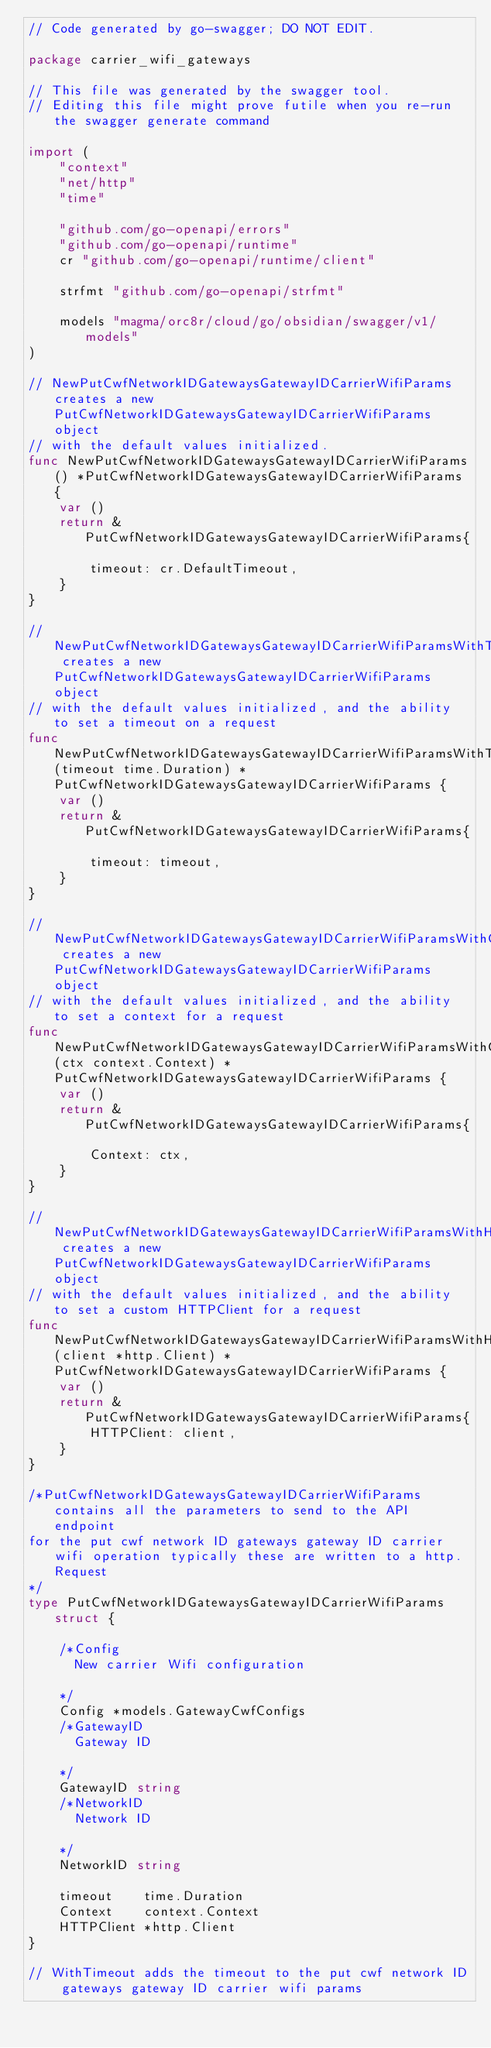<code> <loc_0><loc_0><loc_500><loc_500><_Go_>// Code generated by go-swagger; DO NOT EDIT.

package carrier_wifi_gateways

// This file was generated by the swagger tool.
// Editing this file might prove futile when you re-run the swagger generate command

import (
	"context"
	"net/http"
	"time"

	"github.com/go-openapi/errors"
	"github.com/go-openapi/runtime"
	cr "github.com/go-openapi/runtime/client"

	strfmt "github.com/go-openapi/strfmt"

	models "magma/orc8r/cloud/go/obsidian/swagger/v1/models"
)

// NewPutCwfNetworkIDGatewaysGatewayIDCarrierWifiParams creates a new PutCwfNetworkIDGatewaysGatewayIDCarrierWifiParams object
// with the default values initialized.
func NewPutCwfNetworkIDGatewaysGatewayIDCarrierWifiParams() *PutCwfNetworkIDGatewaysGatewayIDCarrierWifiParams {
	var ()
	return &PutCwfNetworkIDGatewaysGatewayIDCarrierWifiParams{

		timeout: cr.DefaultTimeout,
	}
}

// NewPutCwfNetworkIDGatewaysGatewayIDCarrierWifiParamsWithTimeout creates a new PutCwfNetworkIDGatewaysGatewayIDCarrierWifiParams object
// with the default values initialized, and the ability to set a timeout on a request
func NewPutCwfNetworkIDGatewaysGatewayIDCarrierWifiParamsWithTimeout(timeout time.Duration) *PutCwfNetworkIDGatewaysGatewayIDCarrierWifiParams {
	var ()
	return &PutCwfNetworkIDGatewaysGatewayIDCarrierWifiParams{

		timeout: timeout,
	}
}

// NewPutCwfNetworkIDGatewaysGatewayIDCarrierWifiParamsWithContext creates a new PutCwfNetworkIDGatewaysGatewayIDCarrierWifiParams object
// with the default values initialized, and the ability to set a context for a request
func NewPutCwfNetworkIDGatewaysGatewayIDCarrierWifiParamsWithContext(ctx context.Context) *PutCwfNetworkIDGatewaysGatewayIDCarrierWifiParams {
	var ()
	return &PutCwfNetworkIDGatewaysGatewayIDCarrierWifiParams{

		Context: ctx,
	}
}

// NewPutCwfNetworkIDGatewaysGatewayIDCarrierWifiParamsWithHTTPClient creates a new PutCwfNetworkIDGatewaysGatewayIDCarrierWifiParams object
// with the default values initialized, and the ability to set a custom HTTPClient for a request
func NewPutCwfNetworkIDGatewaysGatewayIDCarrierWifiParamsWithHTTPClient(client *http.Client) *PutCwfNetworkIDGatewaysGatewayIDCarrierWifiParams {
	var ()
	return &PutCwfNetworkIDGatewaysGatewayIDCarrierWifiParams{
		HTTPClient: client,
	}
}

/*PutCwfNetworkIDGatewaysGatewayIDCarrierWifiParams contains all the parameters to send to the API endpoint
for the put cwf network ID gateways gateway ID carrier wifi operation typically these are written to a http.Request
*/
type PutCwfNetworkIDGatewaysGatewayIDCarrierWifiParams struct {

	/*Config
	  New carrier Wifi configuration

	*/
	Config *models.GatewayCwfConfigs
	/*GatewayID
	  Gateway ID

	*/
	GatewayID string
	/*NetworkID
	  Network ID

	*/
	NetworkID string

	timeout    time.Duration
	Context    context.Context
	HTTPClient *http.Client
}

// WithTimeout adds the timeout to the put cwf network ID gateways gateway ID carrier wifi params</code> 